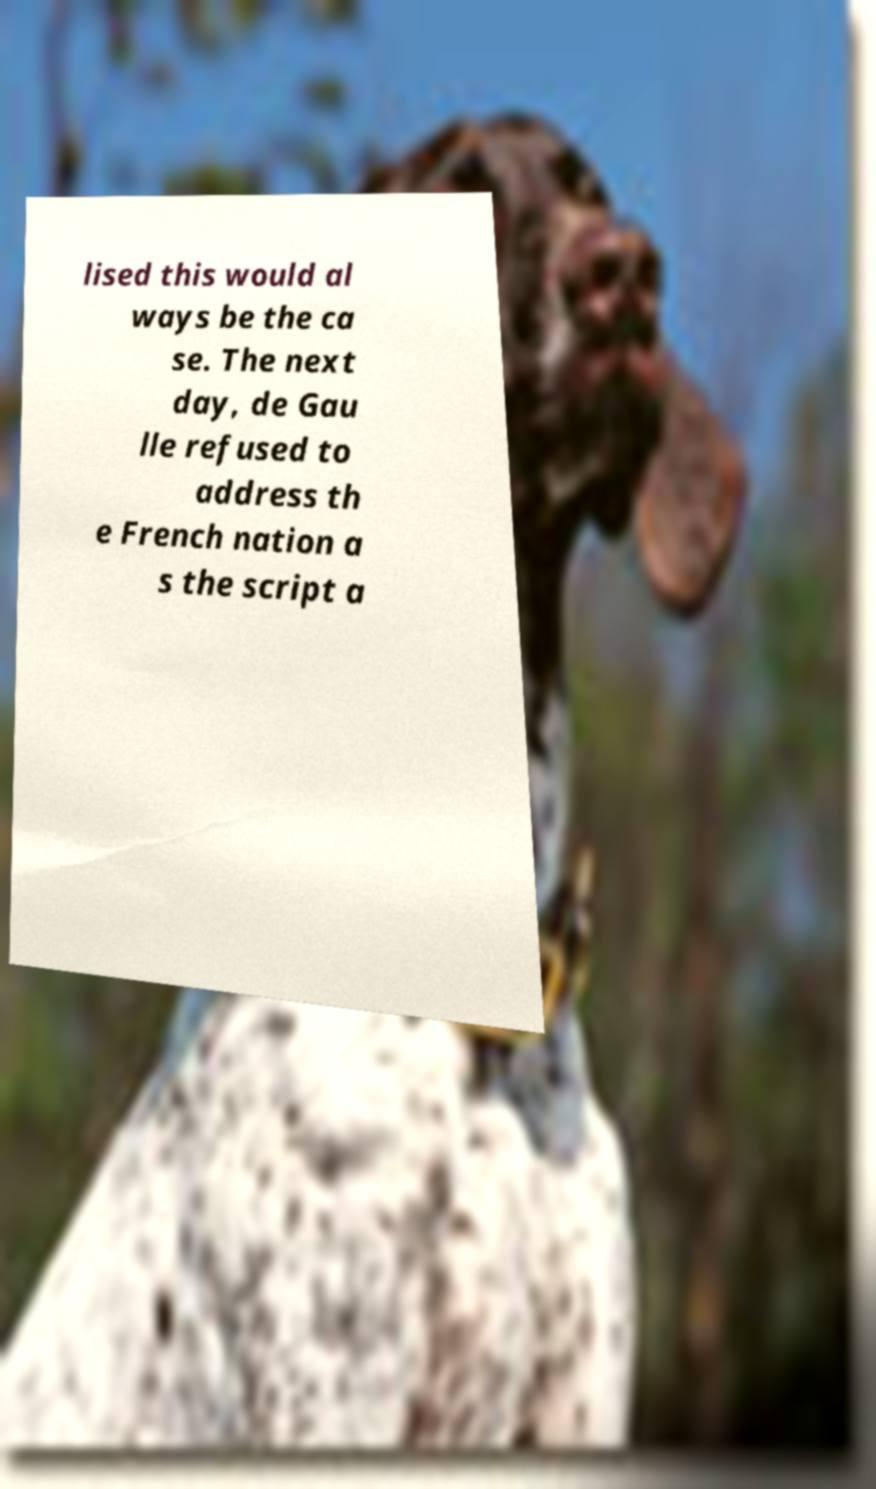Can you read and provide the text displayed in the image?This photo seems to have some interesting text. Can you extract and type it out for me? lised this would al ways be the ca se. The next day, de Gau lle refused to address th e French nation a s the script a 